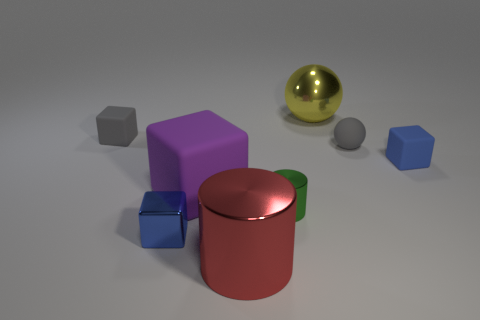How would you describe the composition of objects in this image? The image features a variety of geometric shapes with different colors and materials, arranged on a flat surface. In the foreground, there's a purple cube, a red cylindrical container with a green band and a reflective golden sphere. Behind these, there are a small gray sphere, a larger gray cube, and a smaller blue cube. The arrangement seems intentionally structured to present a contrast of shapes and colors. 